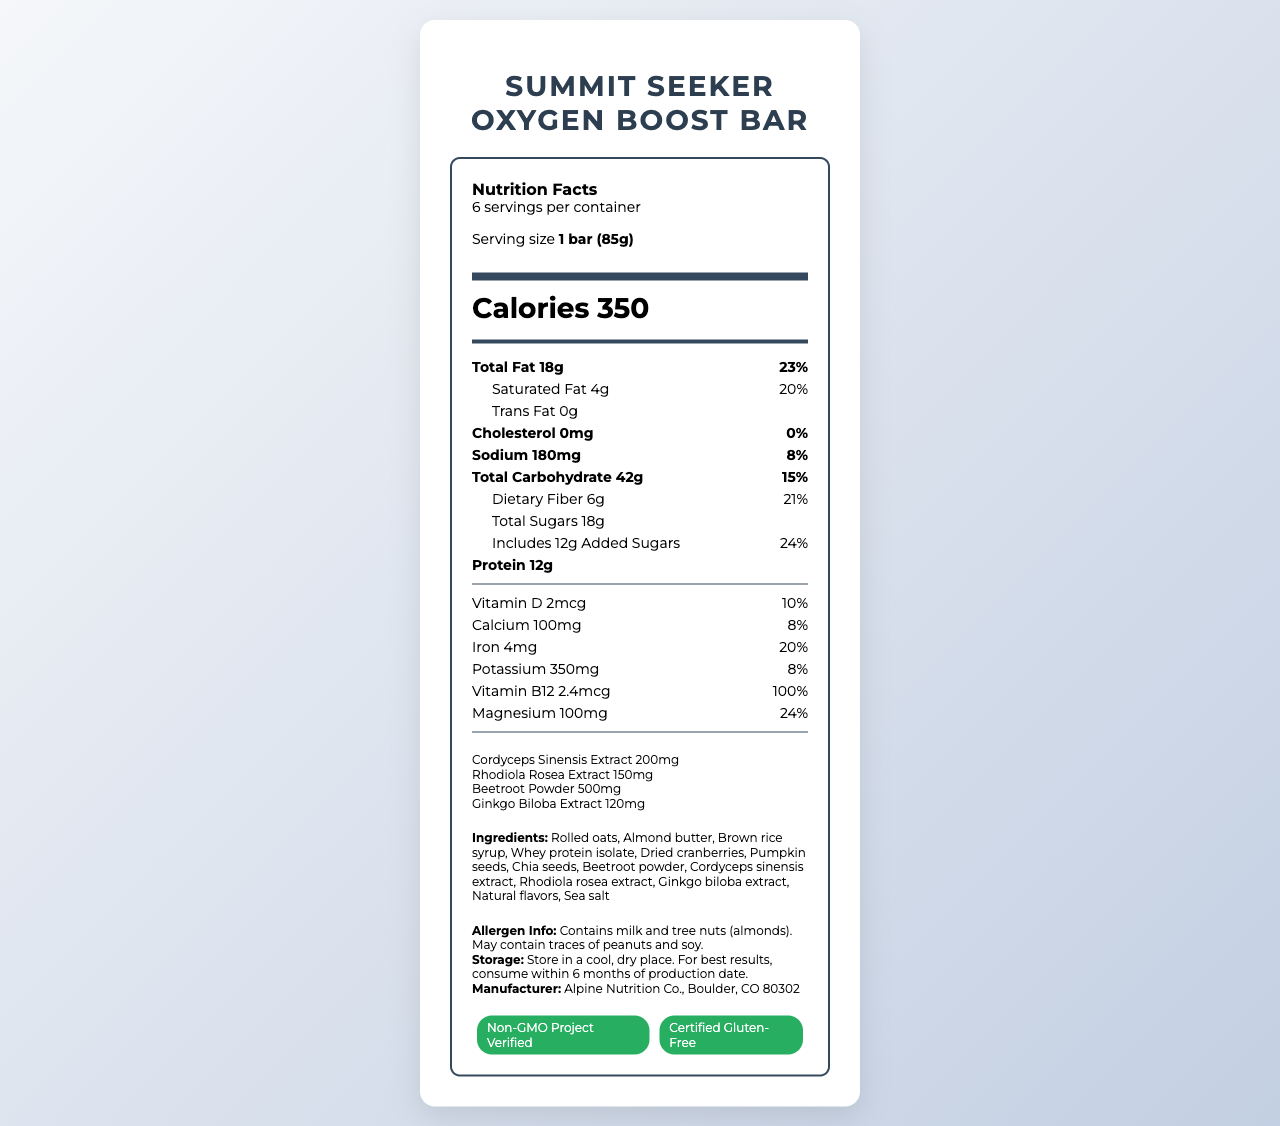What is the serving size of the Summit Seeker Oxygen Boost Bar? The serving size is explicitly stated under the product name as "1 bar (85g)".
Answer: 1 bar (85g) How many calories are in one serving of the bar? The calorie content per serving is listed prominently under the serving size with the label "Calories 350".
Answer: 350 What is the total fat content per serving and its percentage of daily value? Under the "Total Fat" heading, it shows "18g" and "23%" as the daily value.
Answer: 18g, 23% How much protein is in one serving of the bar? The protein content is listed clearly as "Protein 12g".
Answer: 12g Name two ingredients in the bar that help with oxygen-boosting. The ingredients list includes "Cordyceps sinensis extract" and "Rhodiola rosea extract", both known for their potential oxygen-boosting benefits.
Answer: Cordyceps sinensis extract, Rhodiola rosea extract Does the bar contain any trans fat? The label clearly states "Trans Fat 0g".
Answer: No Which of the following nutrients have a daily value of 8%? A. Vitamin B12 B. Calcium C. Iron D. Sodium Calcium and Sodium both have 8% daily value, visible in their respective sections on the label.
Answer: B. Calcium and D. Sodium What is the daily value percentage for dietary fiber in this bar? A. 10% B. 15% C. 21% D. 24% The daily value for dietary fiber is shown as "21%" on the label.
Answer: C. 21% Does this product contain any tree nuts? The allergen information states that it contains tree nuts (almonds).
Answer: Yes Summarize the main nutritional benefits of the Summit Seeker Oxygen Boost Bar. The bar is rich in macronutrients such as fats, carbohydrates, and protein, and contains beneficial vitamins and minerals to support high energy and improve oxygen usage.
Answer: The Summit Seeker Oxygen Boost Bar is designed to provide high energy and aid oxygen availability with 350 calories, 18g of fat, 12g of protein, and added oxygen-boosting ingredients. It is also rich in vitamins and minerals like Vitamin B12, iron, magnesium, and fiber. How many servings are there in one container of the Summit Seeker Oxygen Boost Bar? The document mentions that there are "6 servings per container".
Answer: 6 What is the total weight of one container of bars? The document provides the weight of one bar but does not mention the total weight of the container directly.
Answer: Cannot be determined What does the certification "Non-GMO Project Verified" indicate? "Non-GMO Project Verified" means that the product is certified to be free of GMOs as per the standard set by the Non-GMO Project.
Answer: The product does not contain genetically modified organisms. Is the sodium content in the bar greater than 200mg per serving? The label shows the sodium content as "180mg", which is less than 200mg.
Answer: No What are the storage instructions for the bar? The storage instructions are mentioned in the document under the additional info section.
Answer: Store in a cool, dry place. For best results, consume within 6 months of production date. What is the daily value percentage of Vitamin B12 found in the bar? The daily value percentage for Vitamin B12 is shown as 100% on the label.
Answer: 100% 